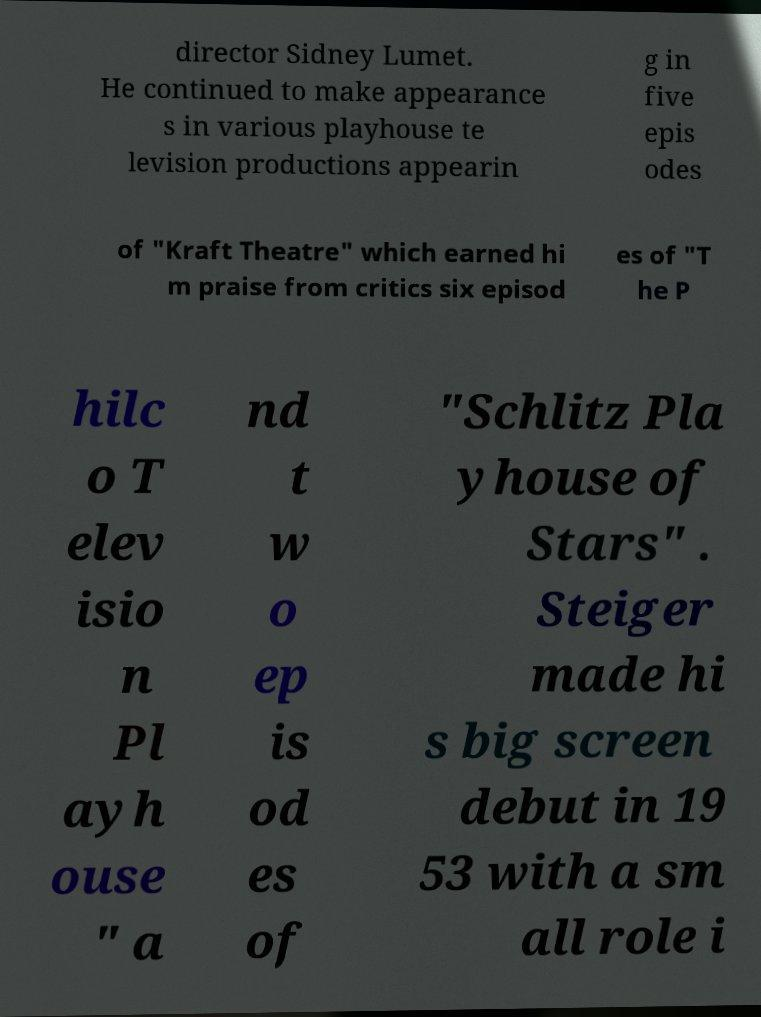Could you extract and type out the text from this image? director Sidney Lumet. He continued to make appearance s in various playhouse te levision productions appearin g in five epis odes of "Kraft Theatre" which earned hi m praise from critics six episod es of "T he P hilc o T elev isio n Pl ayh ouse " a nd t w o ep is od es of "Schlitz Pla yhouse of Stars" . Steiger made hi s big screen debut in 19 53 with a sm all role i 